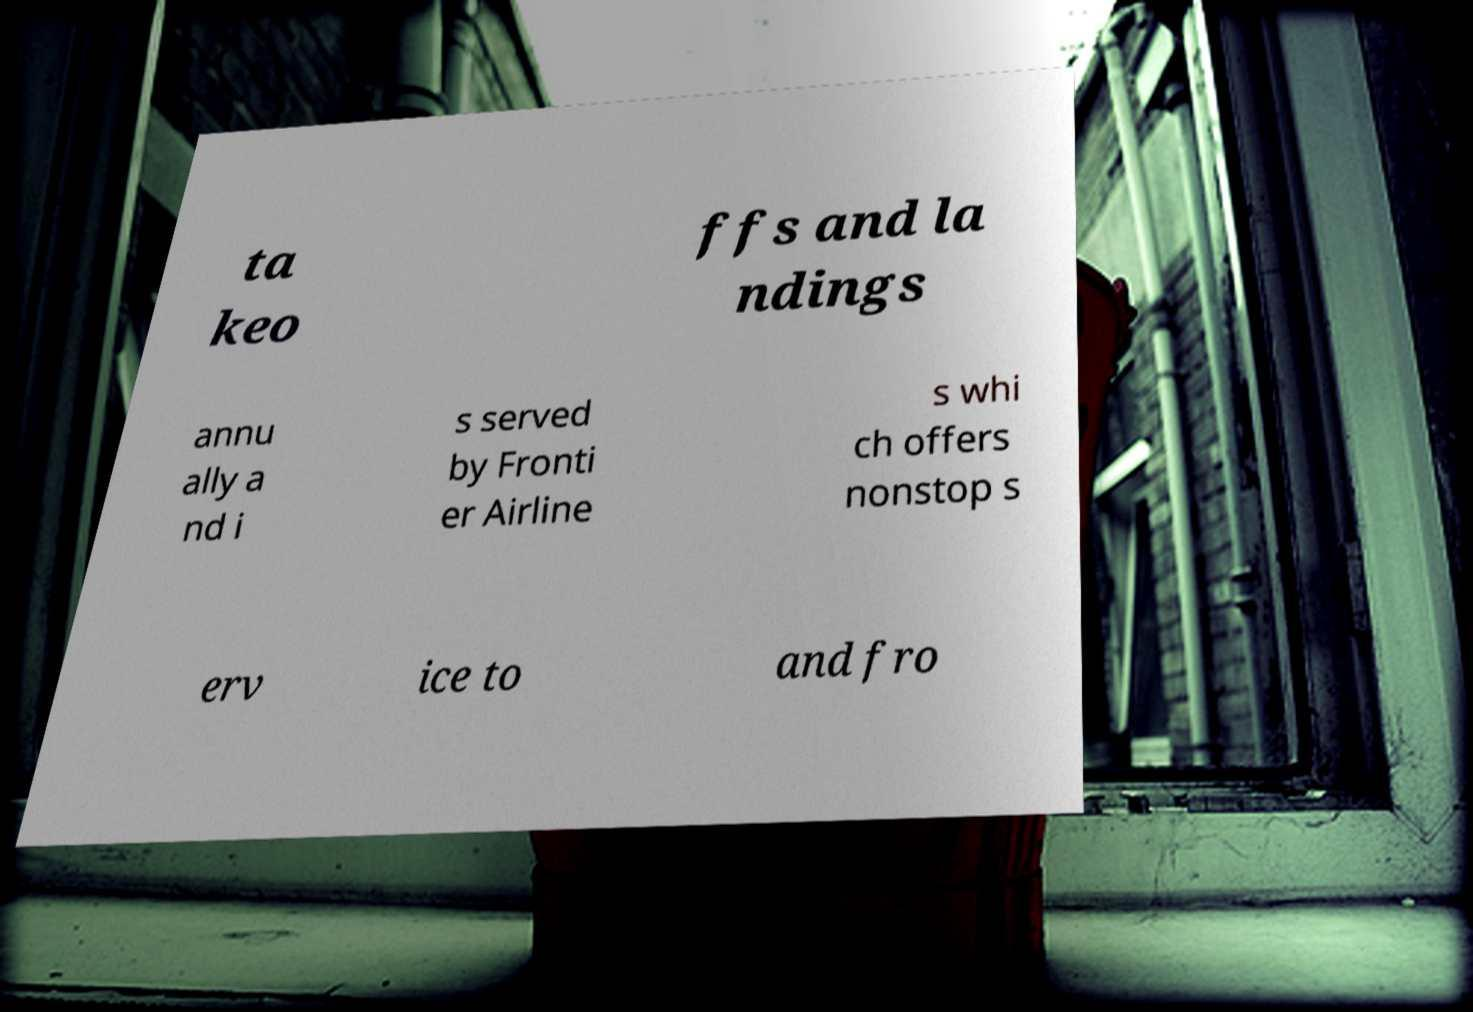For documentation purposes, I need the text within this image transcribed. Could you provide that? ta keo ffs and la ndings annu ally a nd i s served by Fronti er Airline s whi ch offers nonstop s erv ice to and fro 